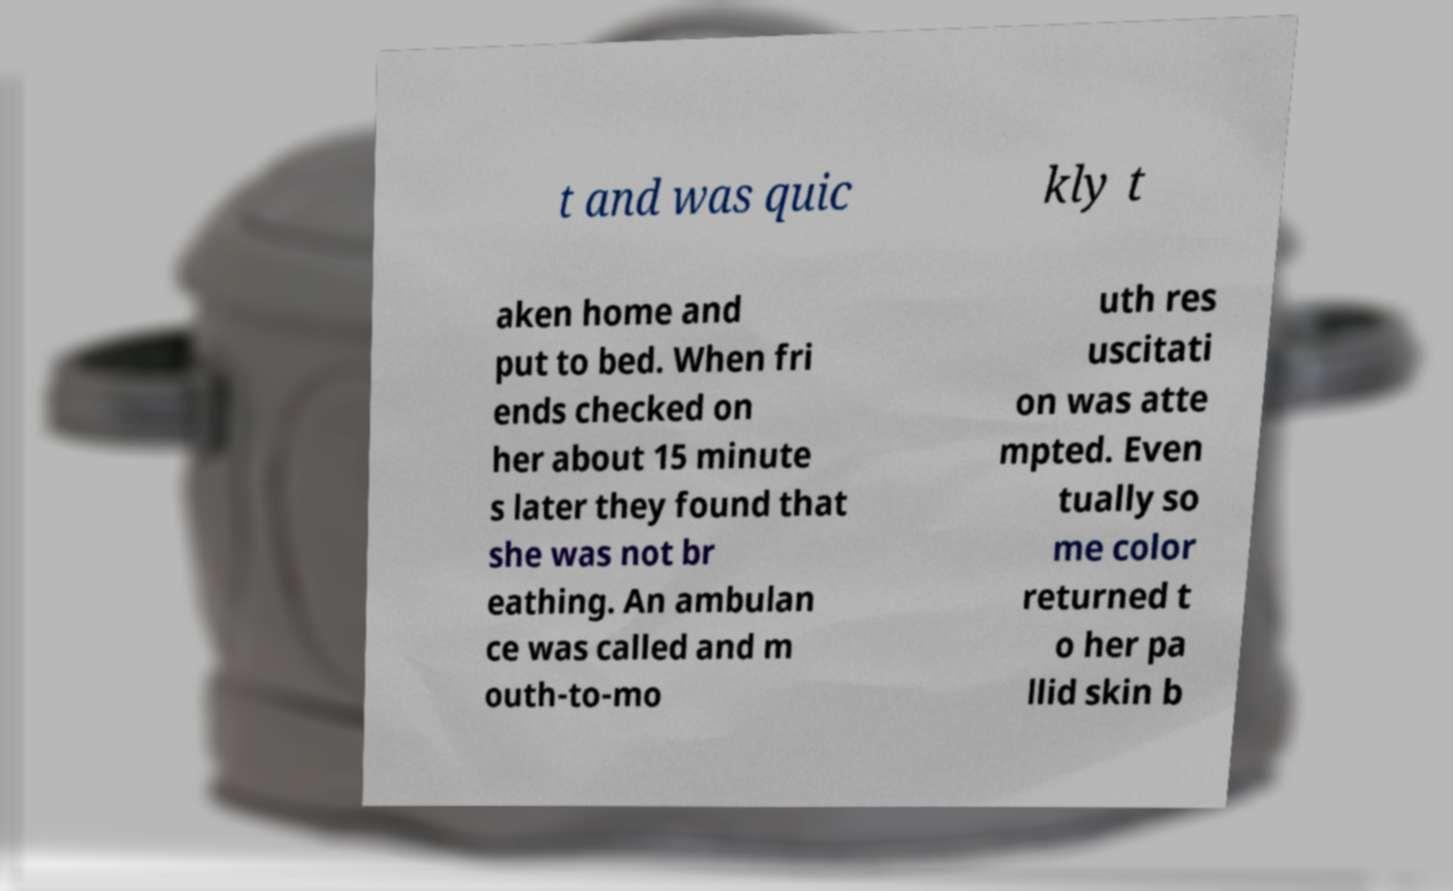What messages or text are displayed in this image? I need them in a readable, typed format. t and was quic kly t aken home and put to bed. When fri ends checked on her about 15 minute s later they found that she was not br eathing. An ambulan ce was called and m outh-to-mo uth res uscitati on was atte mpted. Even tually so me color returned t o her pa llid skin b 